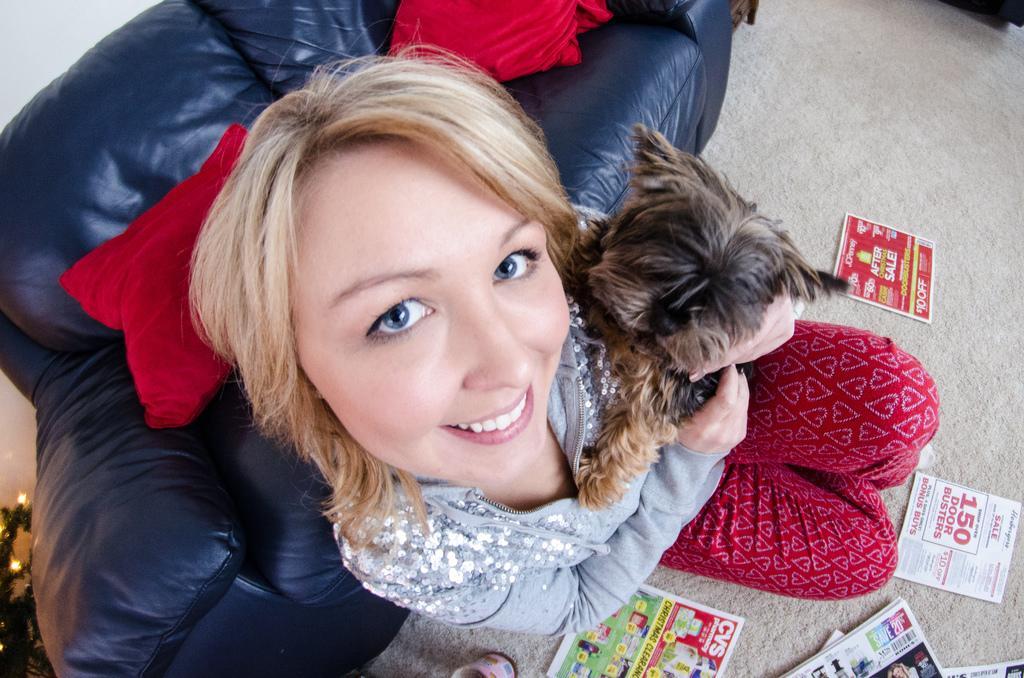How would you summarize this image in a sentence or two? This person sitting on the floor and holding dog,behind this person we can see sofa,wall,on the sofa there are pillows. We can see papers on the floor. 